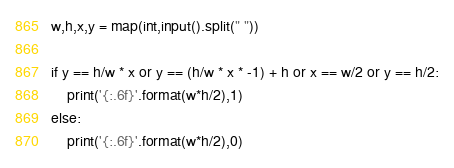<code> <loc_0><loc_0><loc_500><loc_500><_Python_>w,h,x,y = map(int,input().split(" "))

if y == h/w * x or y == (h/w * x * -1) + h or x == w/2 or y == h/2:
    print('{:.6f}'.format(w*h/2),1)
else:
    print('{:.6f}'.format(w*h/2),0)
</code> 